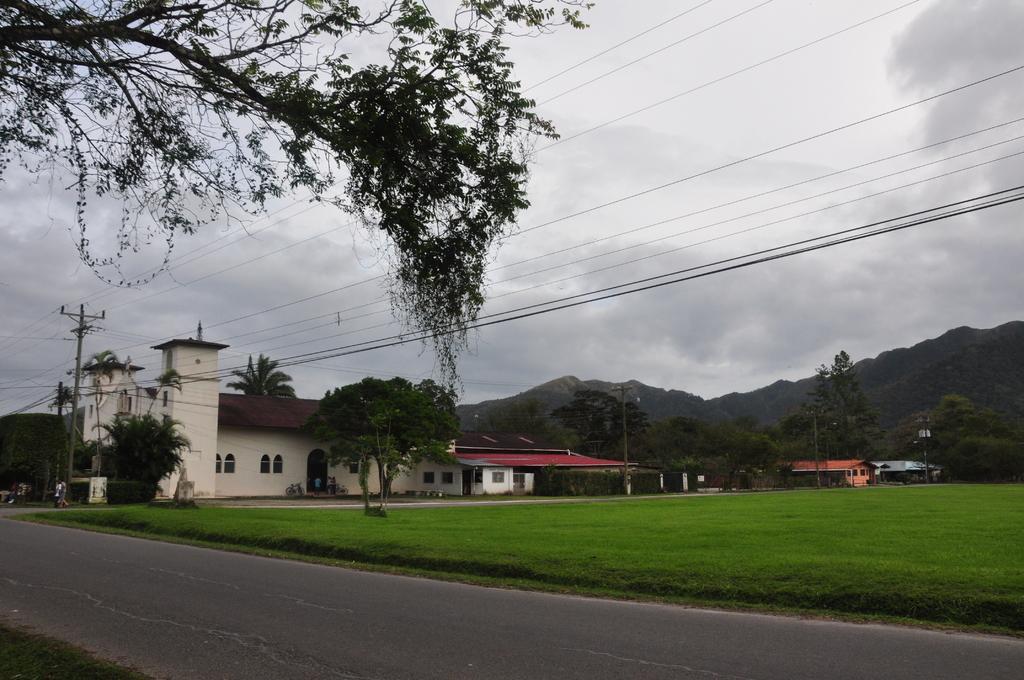Describe this image in one or two sentences. In this image we can see a group of buildings with windows. Two persons are standing on the ground. In the background, we can see a group of trees, poles with cables, mountains and the cloudy sky. 